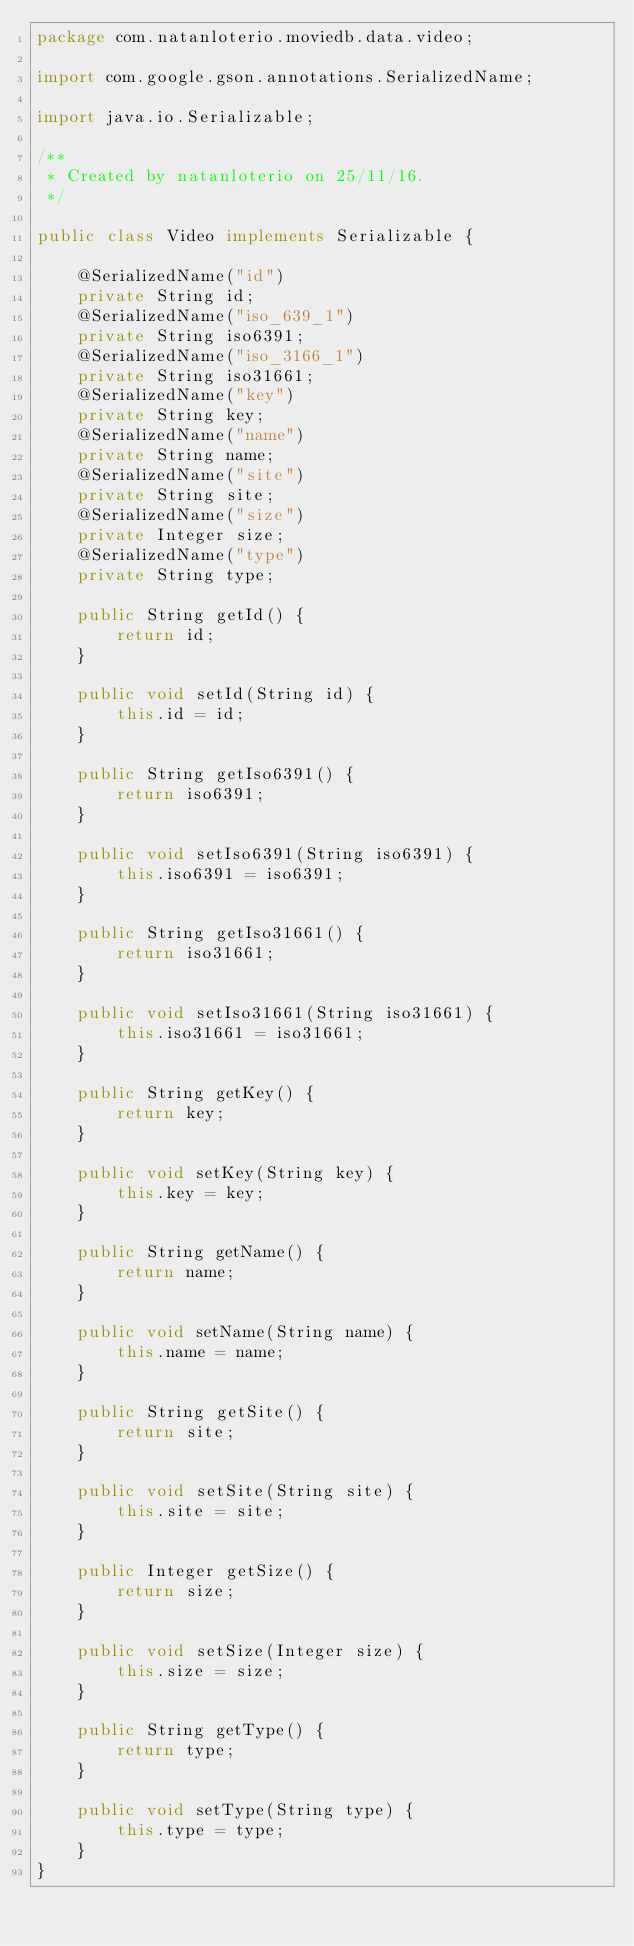Convert code to text. <code><loc_0><loc_0><loc_500><loc_500><_Java_>package com.natanloterio.moviedb.data.video;

import com.google.gson.annotations.SerializedName;

import java.io.Serializable;

/**
 * Created by natanloterio on 25/11/16.
 */

public class Video implements Serializable {

    @SerializedName("id")
    private String id;
    @SerializedName("iso_639_1")
    private String iso6391;
    @SerializedName("iso_3166_1")
    private String iso31661;
    @SerializedName("key")
    private String key;
    @SerializedName("name")
    private String name;
    @SerializedName("site")
    private String site;
    @SerializedName("size")
    private Integer size;
    @SerializedName("type")
    private String type;

    public String getId() {
        return id;
    }

    public void setId(String id) {
        this.id = id;
    }

    public String getIso6391() {
        return iso6391;
    }

    public void setIso6391(String iso6391) {
        this.iso6391 = iso6391;
    }

    public String getIso31661() {
        return iso31661;
    }

    public void setIso31661(String iso31661) {
        this.iso31661 = iso31661;
    }

    public String getKey() {
        return key;
    }

    public void setKey(String key) {
        this.key = key;
    }

    public String getName() {
        return name;
    }

    public void setName(String name) {
        this.name = name;
    }

    public String getSite() {
        return site;
    }

    public void setSite(String site) {
        this.site = site;
    }

    public Integer getSize() {
        return size;
    }

    public void setSize(Integer size) {
        this.size = size;
    }

    public String getType() {
        return type;
    }

    public void setType(String type) {
        this.type = type;
    }
}
</code> 